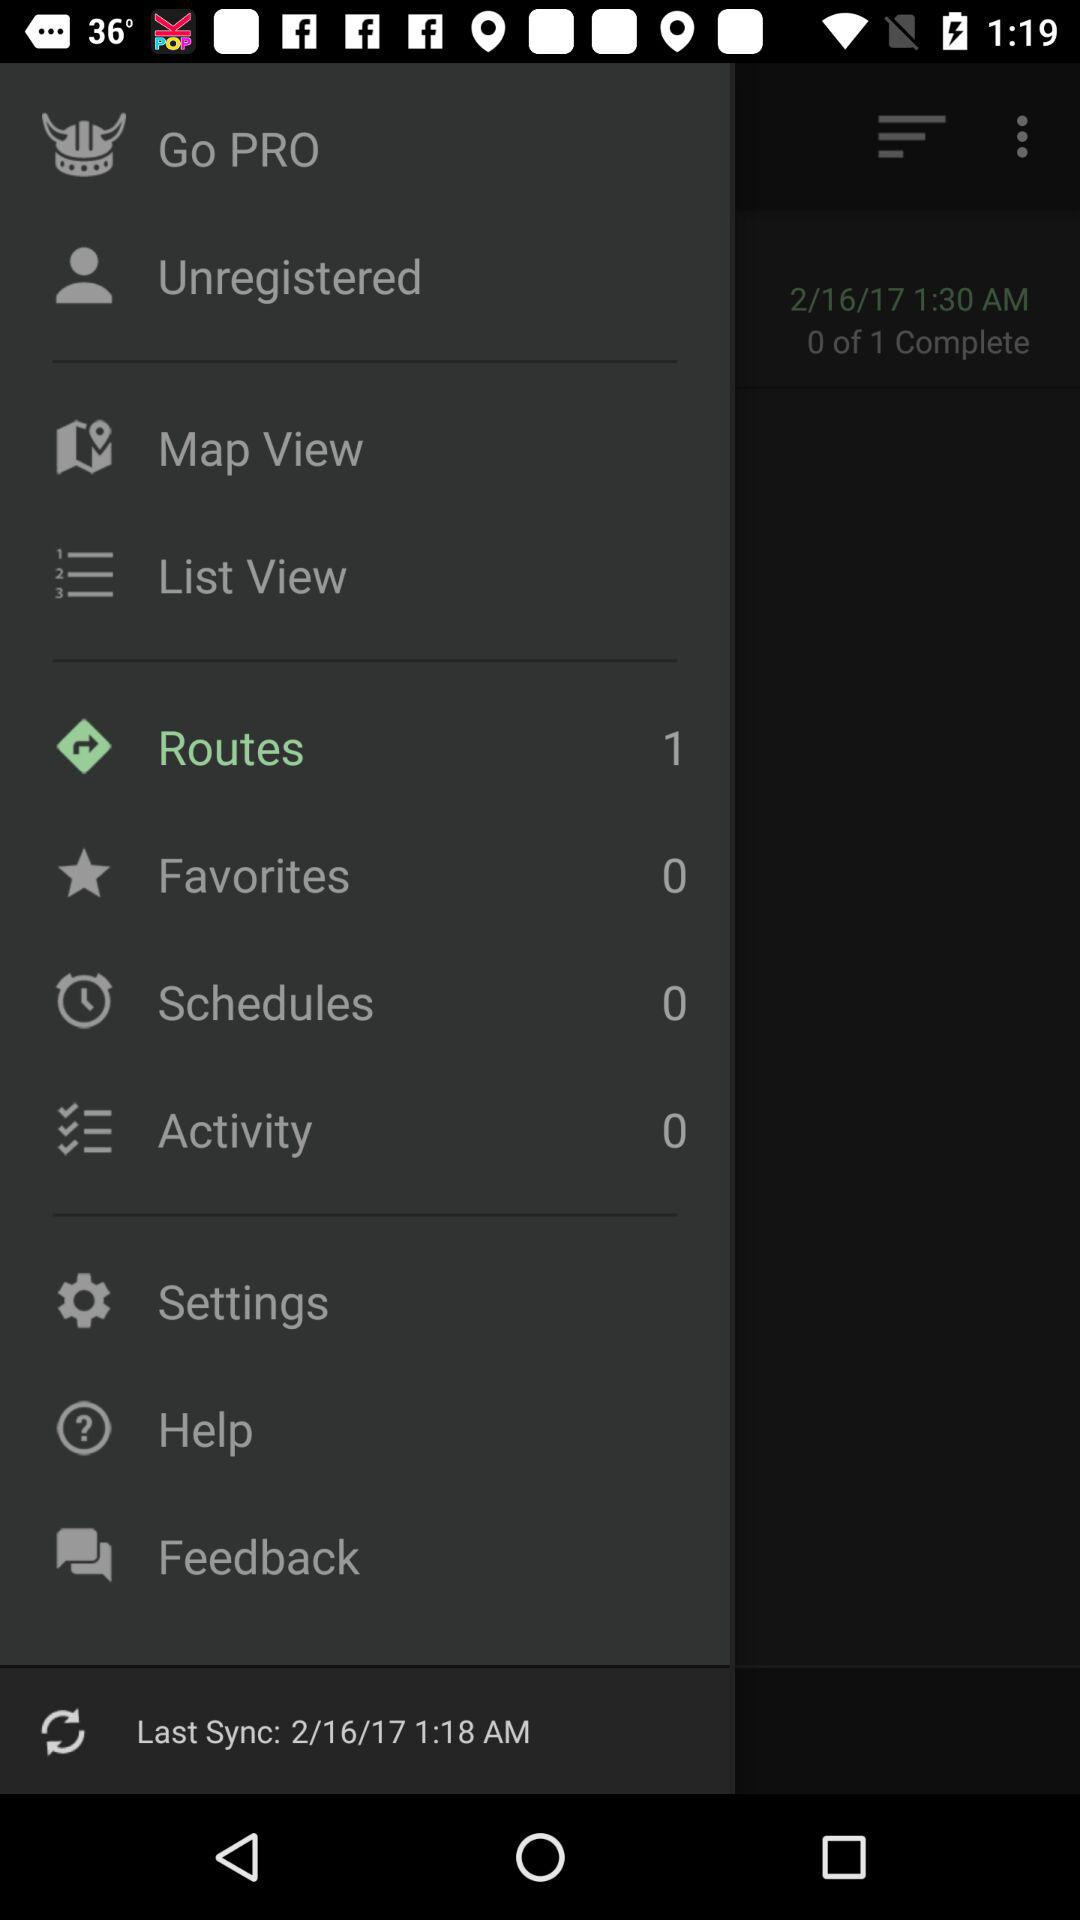When did the last synchronization occur? The last synchronization occurred on February 16, 2017 at 1:18 AM. 